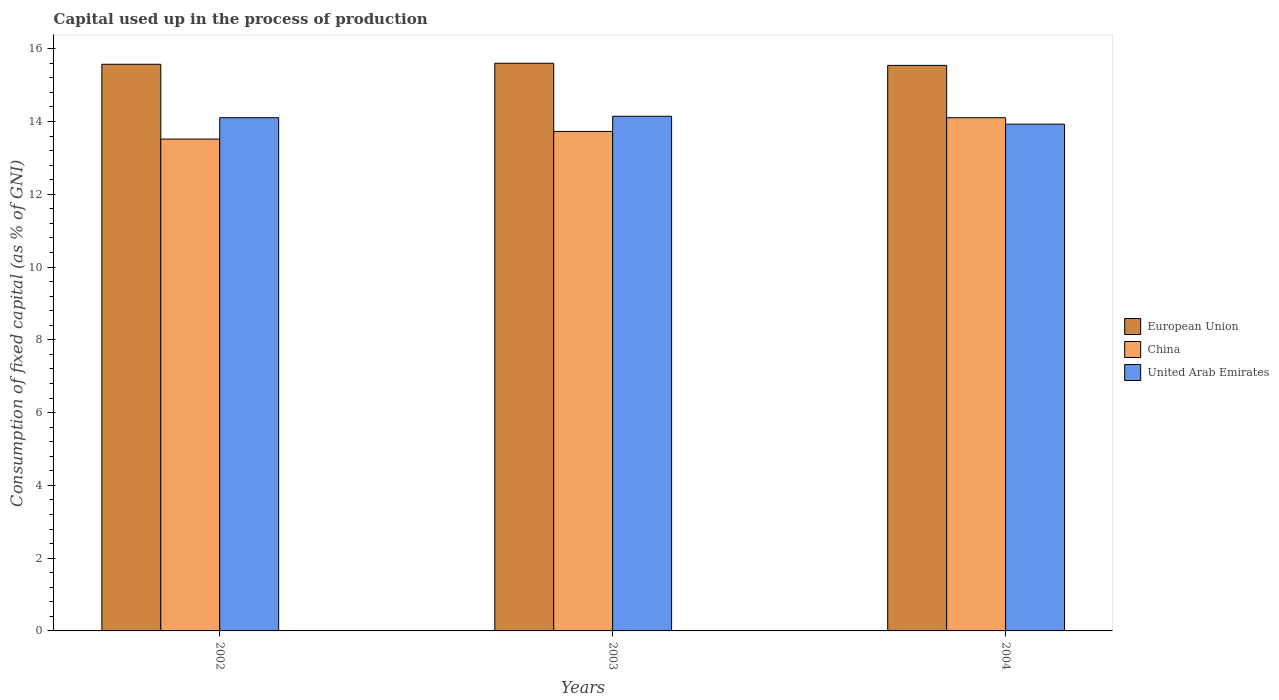How many groups of bars are there?
Keep it short and to the point. 3. Are the number of bars per tick equal to the number of legend labels?
Provide a succinct answer. Yes. How many bars are there on the 3rd tick from the left?
Your response must be concise. 3. How many bars are there on the 3rd tick from the right?
Ensure brevity in your answer.  3. What is the label of the 1st group of bars from the left?
Offer a terse response. 2002. What is the capital used up in the process of production in China in 2003?
Offer a terse response. 13.73. Across all years, what is the maximum capital used up in the process of production in China?
Give a very brief answer. 14.1. Across all years, what is the minimum capital used up in the process of production in European Union?
Offer a terse response. 15.54. In which year was the capital used up in the process of production in China maximum?
Your answer should be compact. 2004. In which year was the capital used up in the process of production in European Union minimum?
Your answer should be very brief. 2004. What is the total capital used up in the process of production in China in the graph?
Make the answer very short. 41.35. What is the difference between the capital used up in the process of production in European Union in 2003 and that in 2004?
Offer a terse response. 0.06. What is the difference between the capital used up in the process of production in China in 2003 and the capital used up in the process of production in United Arab Emirates in 2002?
Your answer should be compact. -0.38. What is the average capital used up in the process of production in European Union per year?
Your response must be concise. 15.57. In the year 2002, what is the difference between the capital used up in the process of production in European Union and capital used up in the process of production in United Arab Emirates?
Give a very brief answer. 1.47. What is the ratio of the capital used up in the process of production in European Union in 2003 to that in 2004?
Make the answer very short. 1. Is the difference between the capital used up in the process of production in European Union in 2002 and 2003 greater than the difference between the capital used up in the process of production in United Arab Emirates in 2002 and 2003?
Your answer should be very brief. Yes. What is the difference between the highest and the second highest capital used up in the process of production in United Arab Emirates?
Provide a short and direct response. 0.04. What is the difference between the highest and the lowest capital used up in the process of production in European Union?
Provide a short and direct response. 0.06. Is it the case that in every year, the sum of the capital used up in the process of production in China and capital used up in the process of production in European Union is greater than the capital used up in the process of production in United Arab Emirates?
Provide a succinct answer. Yes. How many bars are there?
Your answer should be compact. 9. Are all the bars in the graph horizontal?
Ensure brevity in your answer.  No. How many years are there in the graph?
Your answer should be very brief. 3. Does the graph contain any zero values?
Your answer should be compact. No. Does the graph contain grids?
Ensure brevity in your answer.  No. How many legend labels are there?
Provide a short and direct response. 3. How are the legend labels stacked?
Offer a very short reply. Vertical. What is the title of the graph?
Provide a short and direct response. Capital used up in the process of production. Does "Paraguay" appear as one of the legend labels in the graph?
Your answer should be compact. No. What is the label or title of the X-axis?
Ensure brevity in your answer.  Years. What is the label or title of the Y-axis?
Your response must be concise. Consumption of fixed capital (as % of GNI). What is the Consumption of fixed capital (as % of GNI) of European Union in 2002?
Keep it short and to the point. 15.57. What is the Consumption of fixed capital (as % of GNI) in China in 2002?
Provide a short and direct response. 13.52. What is the Consumption of fixed capital (as % of GNI) of United Arab Emirates in 2002?
Give a very brief answer. 14.1. What is the Consumption of fixed capital (as % of GNI) in European Union in 2003?
Your answer should be compact. 15.6. What is the Consumption of fixed capital (as % of GNI) in China in 2003?
Provide a short and direct response. 13.73. What is the Consumption of fixed capital (as % of GNI) of United Arab Emirates in 2003?
Provide a succinct answer. 14.14. What is the Consumption of fixed capital (as % of GNI) of European Union in 2004?
Provide a short and direct response. 15.54. What is the Consumption of fixed capital (as % of GNI) of China in 2004?
Offer a terse response. 14.1. What is the Consumption of fixed capital (as % of GNI) of United Arab Emirates in 2004?
Your answer should be compact. 13.93. Across all years, what is the maximum Consumption of fixed capital (as % of GNI) of European Union?
Your answer should be very brief. 15.6. Across all years, what is the maximum Consumption of fixed capital (as % of GNI) in China?
Ensure brevity in your answer.  14.1. Across all years, what is the maximum Consumption of fixed capital (as % of GNI) in United Arab Emirates?
Provide a short and direct response. 14.14. Across all years, what is the minimum Consumption of fixed capital (as % of GNI) in European Union?
Your response must be concise. 15.54. Across all years, what is the minimum Consumption of fixed capital (as % of GNI) of China?
Provide a succinct answer. 13.52. Across all years, what is the minimum Consumption of fixed capital (as % of GNI) of United Arab Emirates?
Make the answer very short. 13.93. What is the total Consumption of fixed capital (as % of GNI) of European Union in the graph?
Ensure brevity in your answer.  46.71. What is the total Consumption of fixed capital (as % of GNI) in China in the graph?
Provide a succinct answer. 41.35. What is the total Consumption of fixed capital (as % of GNI) of United Arab Emirates in the graph?
Your answer should be very brief. 42.18. What is the difference between the Consumption of fixed capital (as % of GNI) in European Union in 2002 and that in 2003?
Keep it short and to the point. -0.03. What is the difference between the Consumption of fixed capital (as % of GNI) in China in 2002 and that in 2003?
Offer a terse response. -0.21. What is the difference between the Consumption of fixed capital (as % of GNI) of United Arab Emirates in 2002 and that in 2003?
Your answer should be compact. -0.04. What is the difference between the Consumption of fixed capital (as % of GNI) of European Union in 2002 and that in 2004?
Keep it short and to the point. 0.03. What is the difference between the Consumption of fixed capital (as % of GNI) of China in 2002 and that in 2004?
Keep it short and to the point. -0.59. What is the difference between the Consumption of fixed capital (as % of GNI) in United Arab Emirates in 2002 and that in 2004?
Your answer should be compact. 0.18. What is the difference between the Consumption of fixed capital (as % of GNI) in European Union in 2003 and that in 2004?
Offer a very short reply. 0.06. What is the difference between the Consumption of fixed capital (as % of GNI) of China in 2003 and that in 2004?
Offer a very short reply. -0.38. What is the difference between the Consumption of fixed capital (as % of GNI) in United Arab Emirates in 2003 and that in 2004?
Give a very brief answer. 0.22. What is the difference between the Consumption of fixed capital (as % of GNI) in European Union in 2002 and the Consumption of fixed capital (as % of GNI) in China in 2003?
Your answer should be very brief. 1.85. What is the difference between the Consumption of fixed capital (as % of GNI) of European Union in 2002 and the Consumption of fixed capital (as % of GNI) of United Arab Emirates in 2003?
Offer a terse response. 1.43. What is the difference between the Consumption of fixed capital (as % of GNI) in China in 2002 and the Consumption of fixed capital (as % of GNI) in United Arab Emirates in 2003?
Provide a short and direct response. -0.63. What is the difference between the Consumption of fixed capital (as % of GNI) of European Union in 2002 and the Consumption of fixed capital (as % of GNI) of China in 2004?
Give a very brief answer. 1.47. What is the difference between the Consumption of fixed capital (as % of GNI) in European Union in 2002 and the Consumption of fixed capital (as % of GNI) in United Arab Emirates in 2004?
Make the answer very short. 1.65. What is the difference between the Consumption of fixed capital (as % of GNI) in China in 2002 and the Consumption of fixed capital (as % of GNI) in United Arab Emirates in 2004?
Provide a short and direct response. -0.41. What is the difference between the Consumption of fixed capital (as % of GNI) of European Union in 2003 and the Consumption of fixed capital (as % of GNI) of China in 2004?
Offer a terse response. 1.5. What is the difference between the Consumption of fixed capital (as % of GNI) in European Union in 2003 and the Consumption of fixed capital (as % of GNI) in United Arab Emirates in 2004?
Ensure brevity in your answer.  1.67. What is the difference between the Consumption of fixed capital (as % of GNI) in China in 2003 and the Consumption of fixed capital (as % of GNI) in United Arab Emirates in 2004?
Provide a succinct answer. -0.2. What is the average Consumption of fixed capital (as % of GNI) of European Union per year?
Give a very brief answer. 15.57. What is the average Consumption of fixed capital (as % of GNI) in China per year?
Your answer should be compact. 13.78. What is the average Consumption of fixed capital (as % of GNI) in United Arab Emirates per year?
Give a very brief answer. 14.06. In the year 2002, what is the difference between the Consumption of fixed capital (as % of GNI) in European Union and Consumption of fixed capital (as % of GNI) in China?
Provide a succinct answer. 2.06. In the year 2002, what is the difference between the Consumption of fixed capital (as % of GNI) in European Union and Consumption of fixed capital (as % of GNI) in United Arab Emirates?
Offer a very short reply. 1.47. In the year 2002, what is the difference between the Consumption of fixed capital (as % of GNI) in China and Consumption of fixed capital (as % of GNI) in United Arab Emirates?
Make the answer very short. -0.59. In the year 2003, what is the difference between the Consumption of fixed capital (as % of GNI) in European Union and Consumption of fixed capital (as % of GNI) in China?
Your answer should be very brief. 1.87. In the year 2003, what is the difference between the Consumption of fixed capital (as % of GNI) in European Union and Consumption of fixed capital (as % of GNI) in United Arab Emirates?
Offer a terse response. 1.46. In the year 2003, what is the difference between the Consumption of fixed capital (as % of GNI) of China and Consumption of fixed capital (as % of GNI) of United Arab Emirates?
Your answer should be very brief. -0.42. In the year 2004, what is the difference between the Consumption of fixed capital (as % of GNI) of European Union and Consumption of fixed capital (as % of GNI) of China?
Ensure brevity in your answer.  1.44. In the year 2004, what is the difference between the Consumption of fixed capital (as % of GNI) of European Union and Consumption of fixed capital (as % of GNI) of United Arab Emirates?
Provide a short and direct response. 1.61. In the year 2004, what is the difference between the Consumption of fixed capital (as % of GNI) in China and Consumption of fixed capital (as % of GNI) in United Arab Emirates?
Your answer should be very brief. 0.18. What is the ratio of the Consumption of fixed capital (as % of GNI) of European Union in 2002 to that in 2003?
Provide a succinct answer. 1. What is the ratio of the Consumption of fixed capital (as % of GNI) in China in 2002 to that in 2003?
Offer a very short reply. 0.98. What is the ratio of the Consumption of fixed capital (as % of GNI) in United Arab Emirates in 2002 to that in 2003?
Give a very brief answer. 1. What is the ratio of the Consumption of fixed capital (as % of GNI) of European Union in 2002 to that in 2004?
Provide a succinct answer. 1. What is the ratio of the Consumption of fixed capital (as % of GNI) of China in 2002 to that in 2004?
Offer a terse response. 0.96. What is the ratio of the Consumption of fixed capital (as % of GNI) of United Arab Emirates in 2002 to that in 2004?
Your answer should be very brief. 1.01. What is the ratio of the Consumption of fixed capital (as % of GNI) of European Union in 2003 to that in 2004?
Offer a very short reply. 1. What is the ratio of the Consumption of fixed capital (as % of GNI) of China in 2003 to that in 2004?
Give a very brief answer. 0.97. What is the ratio of the Consumption of fixed capital (as % of GNI) in United Arab Emirates in 2003 to that in 2004?
Keep it short and to the point. 1.02. What is the difference between the highest and the second highest Consumption of fixed capital (as % of GNI) in European Union?
Make the answer very short. 0.03. What is the difference between the highest and the second highest Consumption of fixed capital (as % of GNI) in China?
Make the answer very short. 0.38. What is the difference between the highest and the second highest Consumption of fixed capital (as % of GNI) in United Arab Emirates?
Ensure brevity in your answer.  0.04. What is the difference between the highest and the lowest Consumption of fixed capital (as % of GNI) in European Union?
Make the answer very short. 0.06. What is the difference between the highest and the lowest Consumption of fixed capital (as % of GNI) in China?
Offer a very short reply. 0.59. What is the difference between the highest and the lowest Consumption of fixed capital (as % of GNI) of United Arab Emirates?
Your answer should be compact. 0.22. 